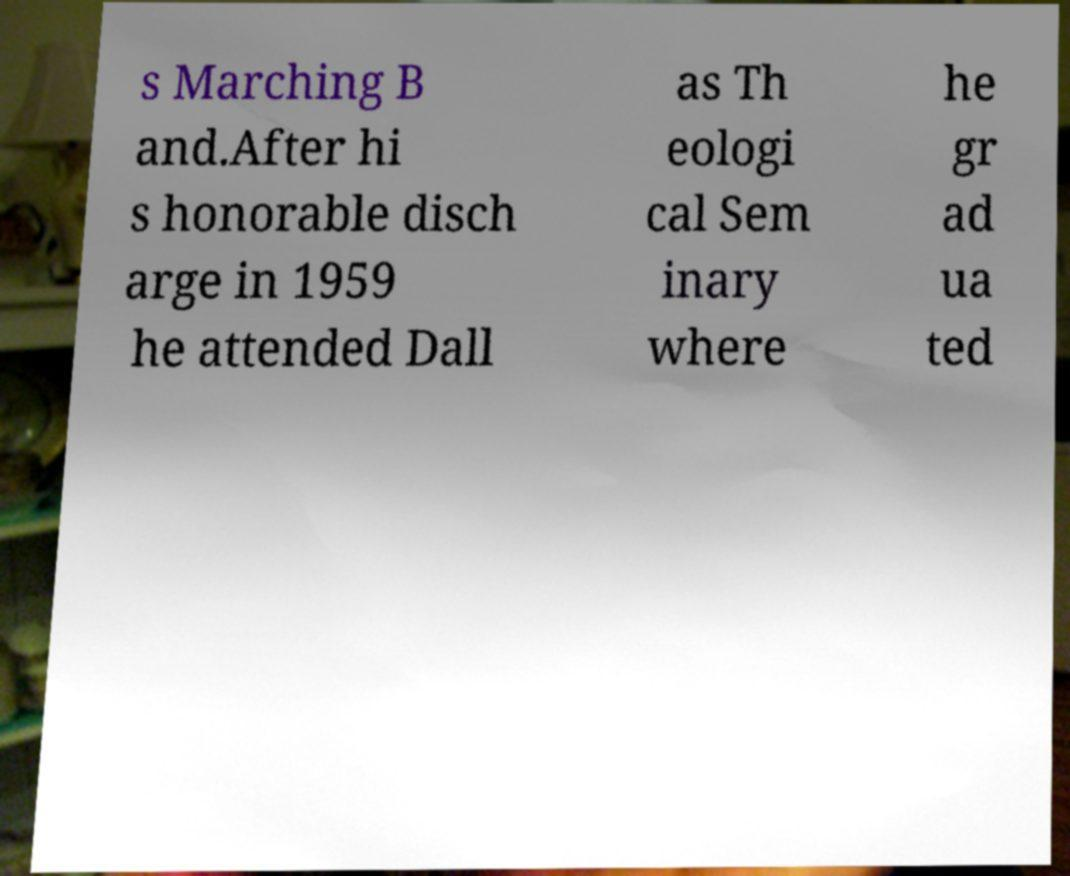Please read and relay the text visible in this image. What does it say? s Marching B and.After hi s honorable disch arge in 1959 he attended Dall as Th eologi cal Sem inary where he gr ad ua ted 